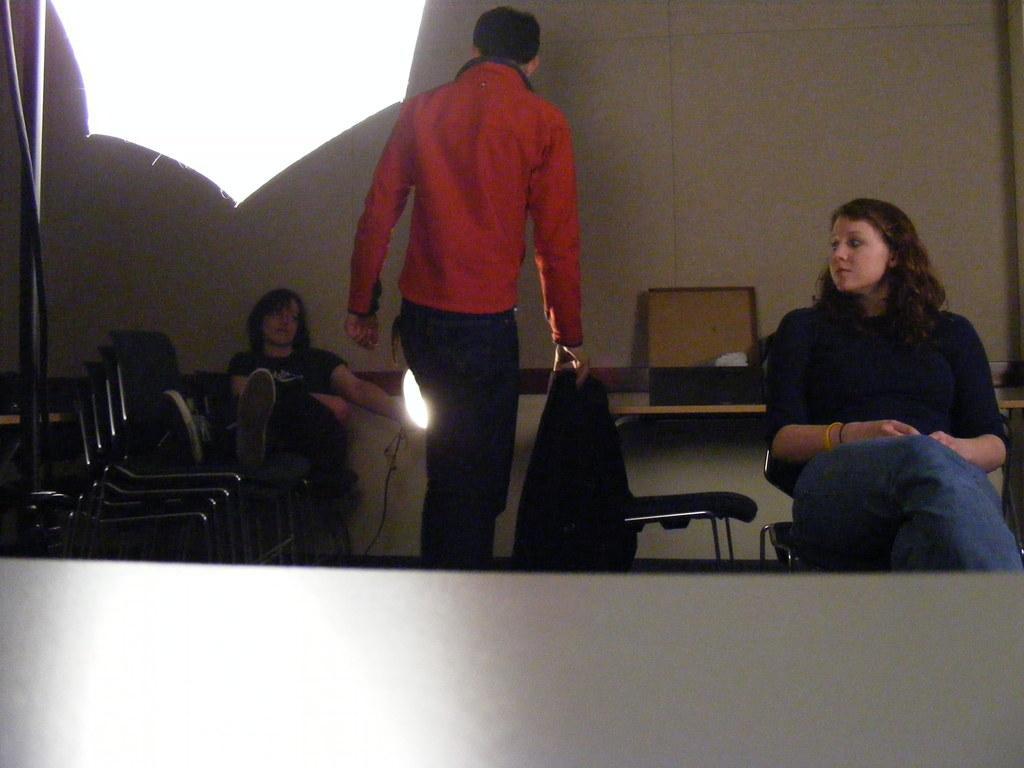How would you summarize this image in a sentence or two? In this image we can see three persons two ladies and a man who is wearing red color shirt and two ladies wearing black color T-shirt sitting on chairs and at the background of the image there is table and wall. 